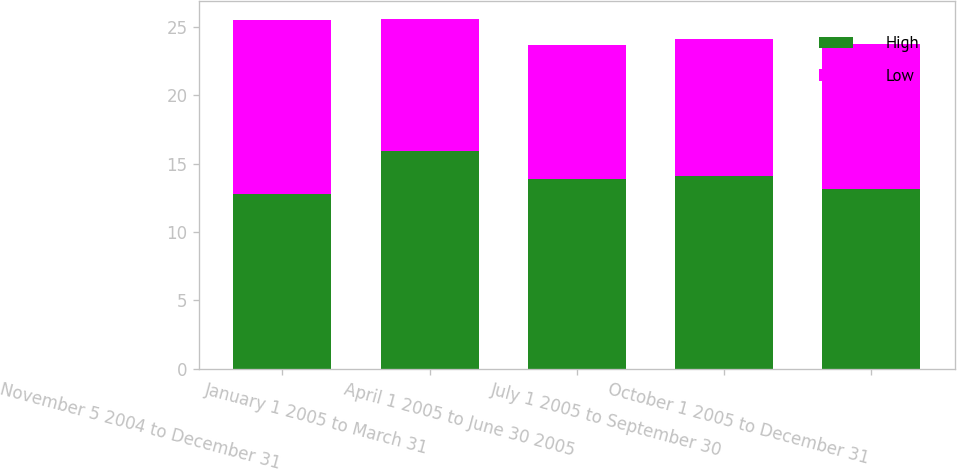Convert chart to OTSL. <chart><loc_0><loc_0><loc_500><loc_500><stacked_bar_chart><ecel><fcel>November 5 2004 to December 31<fcel>January 1 2005 to March 31<fcel>April 1 2005 to June 30 2005<fcel>July 1 2005 to September 30<fcel>October 1 2005 to December 31<nl><fcel>High<fcel>12.75<fcel>15.95<fcel>13.87<fcel>14.09<fcel>13.14<nl><fcel>Low<fcel>12.75<fcel>9.64<fcel>9.83<fcel>9.99<fcel>10.64<nl></chart> 